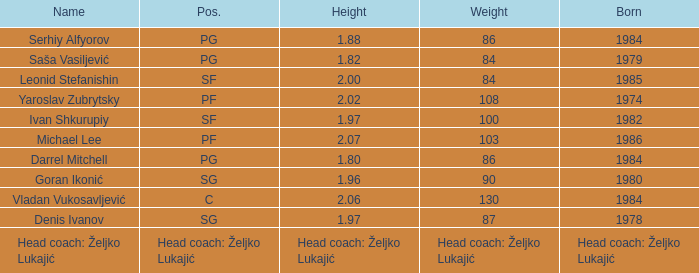What was the weight of Serhiy Alfyorov? 86.0. 